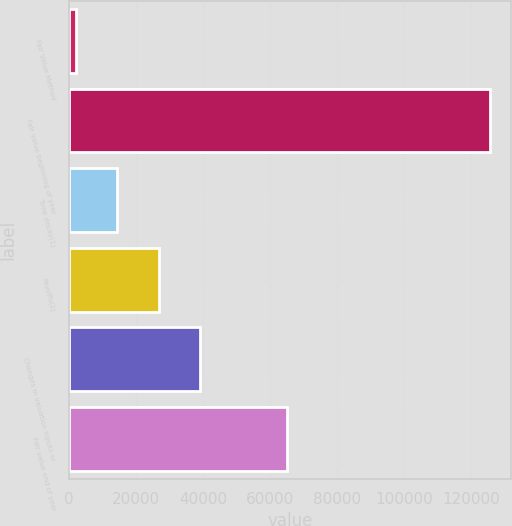Convert chart. <chart><loc_0><loc_0><loc_500><loc_500><bar_chart><fcel>Fair Value Method<fcel>Fair value beginning of year<fcel>Time decay(1)<fcel>Payoffs(2)<fcel>Changes in valuation inputs or<fcel>Fair value end of year<nl><fcel>2011<fcel>125679<fcel>14377.8<fcel>26744.6<fcel>39111.4<fcel>65001<nl></chart> 